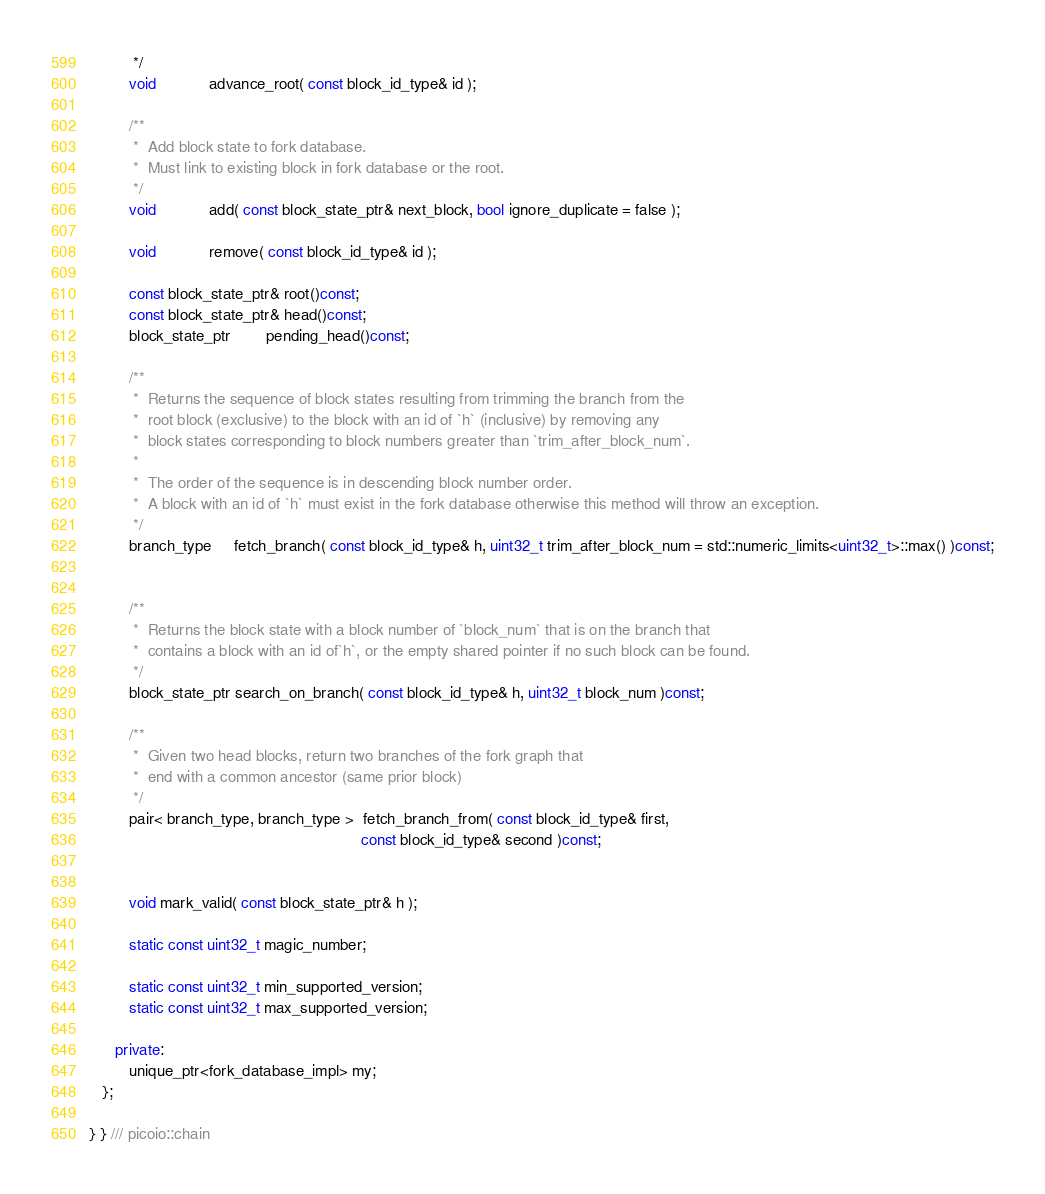<code> <loc_0><loc_0><loc_500><loc_500><_C++_>          */
         void            advance_root( const block_id_type& id );

         /**
          *  Add block state to fork database.
          *  Must link to existing block in fork database or the root.
          */
         void            add( const block_state_ptr& next_block, bool ignore_duplicate = false );

         void            remove( const block_id_type& id );

         const block_state_ptr& root()const;
         const block_state_ptr& head()const;
         block_state_ptr        pending_head()const;

         /**
          *  Returns the sequence of block states resulting from trimming the branch from the
          *  root block (exclusive) to the block with an id of `h` (inclusive) by removing any
          *  block states corresponding to block numbers greater than `trim_after_block_num`.
          *
          *  The order of the sequence is in descending block number order.
          *  A block with an id of `h` must exist in the fork database otherwise this method will throw an exception.
          */
         branch_type     fetch_branch( const block_id_type& h, uint32_t trim_after_block_num = std::numeric_limits<uint32_t>::max() )const;


         /**
          *  Returns the block state with a block number of `block_num` that is on the branch that
          *  contains a block with an id of`h`, or the empty shared pointer if no such block can be found.
          */
         block_state_ptr search_on_branch( const block_id_type& h, uint32_t block_num )const;

         /**
          *  Given two head blocks, return two branches of the fork graph that
          *  end with a common ancestor (same prior block)
          */
         pair< branch_type, branch_type >  fetch_branch_from( const block_id_type& first,
                                                              const block_id_type& second )const;


         void mark_valid( const block_state_ptr& h );

         static const uint32_t magic_number;

         static const uint32_t min_supported_version;
         static const uint32_t max_supported_version;

      private:
         unique_ptr<fork_database_impl> my;
   };

} } /// picoio::chain
</code> 